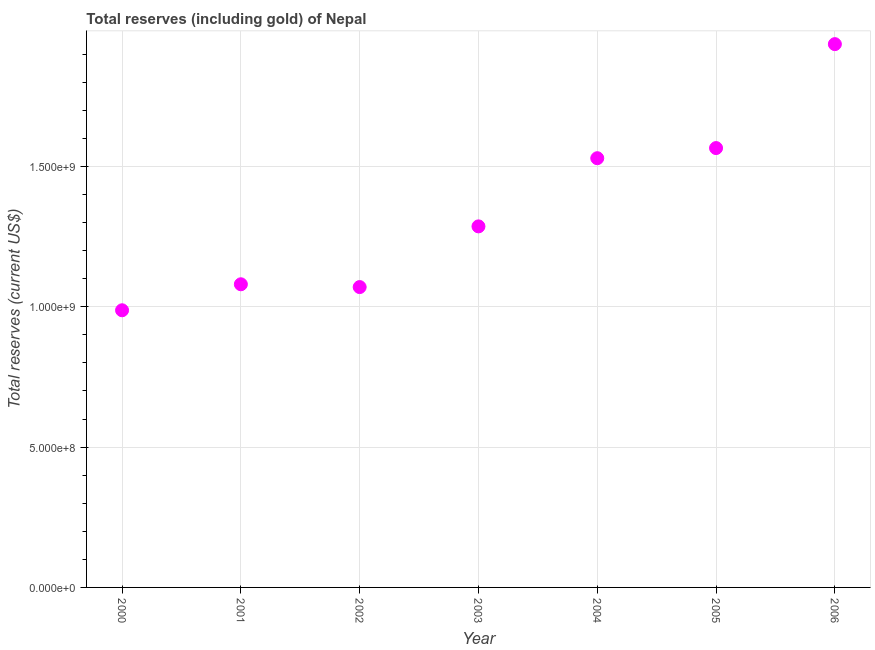What is the total reserves (including gold) in 2002?
Give a very brief answer. 1.07e+09. Across all years, what is the maximum total reserves (including gold)?
Offer a very short reply. 1.94e+09. Across all years, what is the minimum total reserves (including gold)?
Your answer should be very brief. 9.87e+08. In which year was the total reserves (including gold) maximum?
Keep it short and to the point. 2006. In which year was the total reserves (including gold) minimum?
Your response must be concise. 2000. What is the sum of the total reserves (including gold)?
Offer a very short reply. 9.45e+09. What is the difference between the total reserves (including gold) in 2001 and 2006?
Your response must be concise. -8.56e+08. What is the average total reserves (including gold) per year?
Keep it short and to the point. 1.35e+09. What is the median total reserves (including gold)?
Your response must be concise. 1.29e+09. In how many years, is the total reserves (including gold) greater than 500000000 US$?
Offer a terse response. 7. What is the ratio of the total reserves (including gold) in 2002 to that in 2004?
Your answer should be very brief. 0.7. Is the total reserves (including gold) in 2000 less than that in 2006?
Your answer should be very brief. Yes. What is the difference between the highest and the second highest total reserves (including gold)?
Provide a succinct answer. 3.70e+08. Is the sum of the total reserves (including gold) in 2003 and 2004 greater than the maximum total reserves (including gold) across all years?
Give a very brief answer. Yes. What is the difference between the highest and the lowest total reserves (including gold)?
Your answer should be compact. 9.48e+08. Does the total reserves (including gold) monotonically increase over the years?
Ensure brevity in your answer.  No. What is the difference between two consecutive major ticks on the Y-axis?
Offer a very short reply. 5.00e+08. Are the values on the major ticks of Y-axis written in scientific E-notation?
Give a very brief answer. Yes. Does the graph contain any zero values?
Ensure brevity in your answer.  No. Does the graph contain grids?
Offer a terse response. Yes. What is the title of the graph?
Give a very brief answer. Total reserves (including gold) of Nepal. What is the label or title of the Y-axis?
Provide a short and direct response. Total reserves (current US$). What is the Total reserves (current US$) in 2000?
Provide a short and direct response. 9.87e+08. What is the Total reserves (current US$) in 2001?
Your answer should be compact. 1.08e+09. What is the Total reserves (current US$) in 2002?
Keep it short and to the point. 1.07e+09. What is the Total reserves (current US$) in 2003?
Give a very brief answer. 1.29e+09. What is the Total reserves (current US$) in 2004?
Offer a terse response. 1.53e+09. What is the Total reserves (current US$) in 2005?
Give a very brief answer. 1.57e+09. What is the Total reserves (current US$) in 2006?
Keep it short and to the point. 1.94e+09. What is the difference between the Total reserves (current US$) in 2000 and 2001?
Offer a terse response. -9.26e+07. What is the difference between the Total reserves (current US$) in 2000 and 2002?
Your response must be concise. -8.27e+07. What is the difference between the Total reserves (current US$) in 2000 and 2003?
Offer a terse response. -2.99e+08. What is the difference between the Total reserves (current US$) in 2000 and 2004?
Your answer should be very brief. -5.42e+08. What is the difference between the Total reserves (current US$) in 2000 and 2005?
Make the answer very short. -5.78e+08. What is the difference between the Total reserves (current US$) in 2000 and 2006?
Ensure brevity in your answer.  -9.48e+08. What is the difference between the Total reserves (current US$) in 2001 and 2002?
Provide a short and direct response. 9.96e+06. What is the difference between the Total reserves (current US$) in 2001 and 2003?
Your response must be concise. -2.06e+08. What is the difference between the Total reserves (current US$) in 2001 and 2004?
Give a very brief answer. -4.49e+08. What is the difference between the Total reserves (current US$) in 2001 and 2005?
Keep it short and to the point. -4.85e+08. What is the difference between the Total reserves (current US$) in 2001 and 2006?
Offer a very short reply. -8.56e+08. What is the difference between the Total reserves (current US$) in 2002 and 2003?
Your response must be concise. -2.16e+08. What is the difference between the Total reserves (current US$) in 2002 and 2004?
Your answer should be compact. -4.59e+08. What is the difference between the Total reserves (current US$) in 2002 and 2005?
Your answer should be compact. -4.95e+08. What is the difference between the Total reserves (current US$) in 2002 and 2006?
Make the answer very short. -8.65e+08. What is the difference between the Total reserves (current US$) in 2003 and 2004?
Give a very brief answer. -2.43e+08. What is the difference between the Total reserves (current US$) in 2003 and 2005?
Provide a succinct answer. -2.79e+08. What is the difference between the Total reserves (current US$) in 2003 and 2006?
Offer a terse response. -6.49e+08. What is the difference between the Total reserves (current US$) in 2004 and 2005?
Provide a succinct answer. -3.61e+07. What is the difference between the Total reserves (current US$) in 2004 and 2006?
Give a very brief answer. -4.06e+08. What is the difference between the Total reserves (current US$) in 2005 and 2006?
Give a very brief answer. -3.70e+08. What is the ratio of the Total reserves (current US$) in 2000 to that in 2001?
Make the answer very short. 0.91. What is the ratio of the Total reserves (current US$) in 2000 to that in 2002?
Make the answer very short. 0.92. What is the ratio of the Total reserves (current US$) in 2000 to that in 2003?
Provide a succinct answer. 0.77. What is the ratio of the Total reserves (current US$) in 2000 to that in 2004?
Offer a very short reply. 0.65. What is the ratio of the Total reserves (current US$) in 2000 to that in 2005?
Provide a succinct answer. 0.63. What is the ratio of the Total reserves (current US$) in 2000 to that in 2006?
Your answer should be compact. 0.51. What is the ratio of the Total reserves (current US$) in 2001 to that in 2002?
Keep it short and to the point. 1.01. What is the ratio of the Total reserves (current US$) in 2001 to that in 2003?
Your answer should be compact. 0.84. What is the ratio of the Total reserves (current US$) in 2001 to that in 2004?
Offer a terse response. 0.71. What is the ratio of the Total reserves (current US$) in 2001 to that in 2005?
Your answer should be compact. 0.69. What is the ratio of the Total reserves (current US$) in 2001 to that in 2006?
Your answer should be very brief. 0.56. What is the ratio of the Total reserves (current US$) in 2002 to that in 2003?
Your response must be concise. 0.83. What is the ratio of the Total reserves (current US$) in 2002 to that in 2004?
Your response must be concise. 0.7. What is the ratio of the Total reserves (current US$) in 2002 to that in 2005?
Provide a short and direct response. 0.68. What is the ratio of the Total reserves (current US$) in 2002 to that in 2006?
Your answer should be very brief. 0.55. What is the ratio of the Total reserves (current US$) in 2003 to that in 2004?
Your response must be concise. 0.84. What is the ratio of the Total reserves (current US$) in 2003 to that in 2005?
Provide a short and direct response. 0.82. What is the ratio of the Total reserves (current US$) in 2003 to that in 2006?
Keep it short and to the point. 0.67. What is the ratio of the Total reserves (current US$) in 2004 to that in 2005?
Provide a short and direct response. 0.98. What is the ratio of the Total reserves (current US$) in 2004 to that in 2006?
Your answer should be compact. 0.79. What is the ratio of the Total reserves (current US$) in 2005 to that in 2006?
Keep it short and to the point. 0.81. 